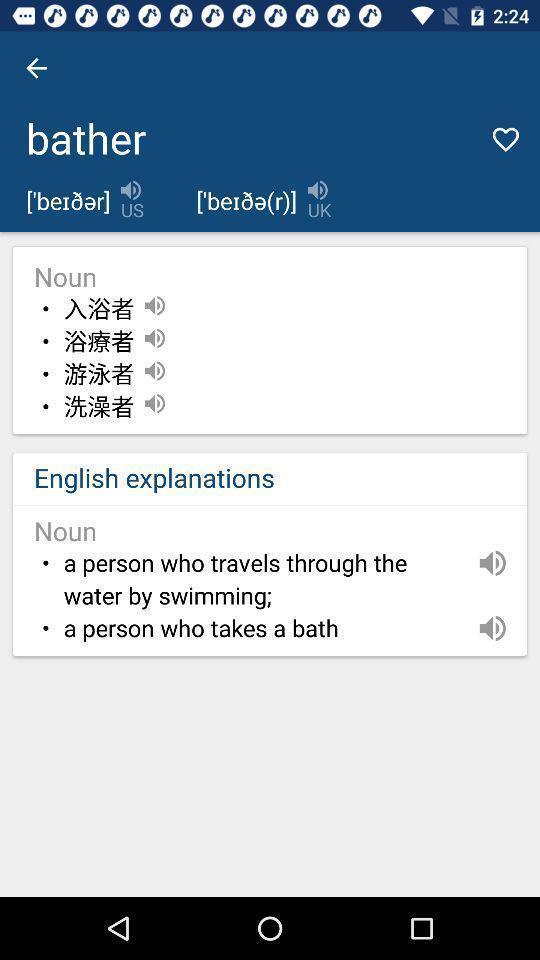Describe the key features of this screenshot. Screen showing page of an translator application. 